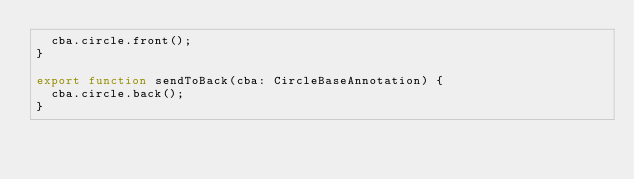<code> <loc_0><loc_0><loc_500><loc_500><_TypeScript_>  cba.circle.front();
}

export function sendToBack(cba: CircleBaseAnnotation) {
  cba.circle.back();
}
</code> 